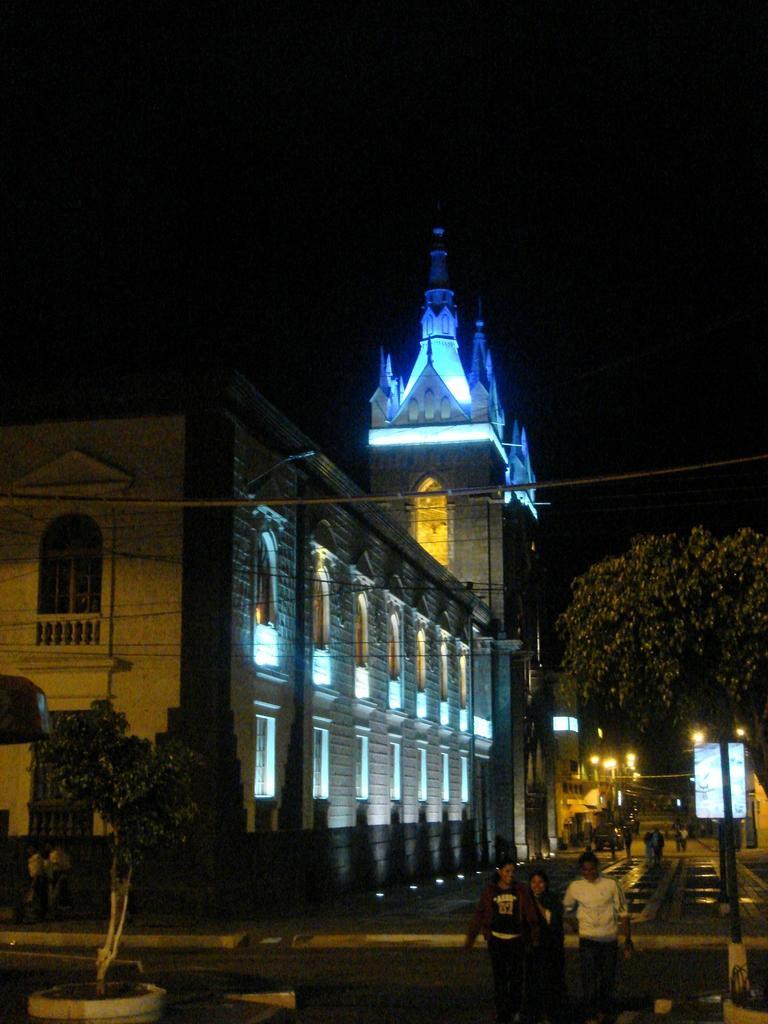Describe this image in one or two sentences. In the picture I can see buildings, trees, street lights and people on the ground. In the background I can see a board and the sky. 